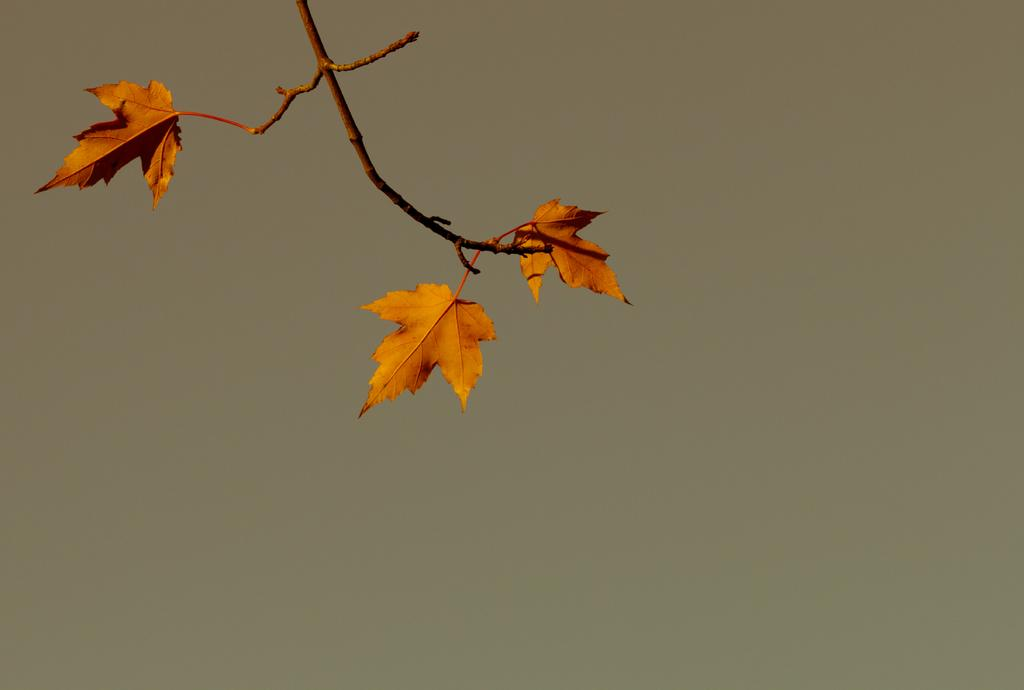What is present in the picture? There is a plant in the picture. How many leaves does the plant have? The plant has three leaves. What color is the background of the image? The background of the image is light brown in color. What type of caption is written on the edge of the plant? There is no caption written on the edge of the plant, as it is a living organism and not a text-based object. 